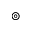<formula> <loc_0><loc_0><loc_500><loc_500>\circledcirc</formula> 